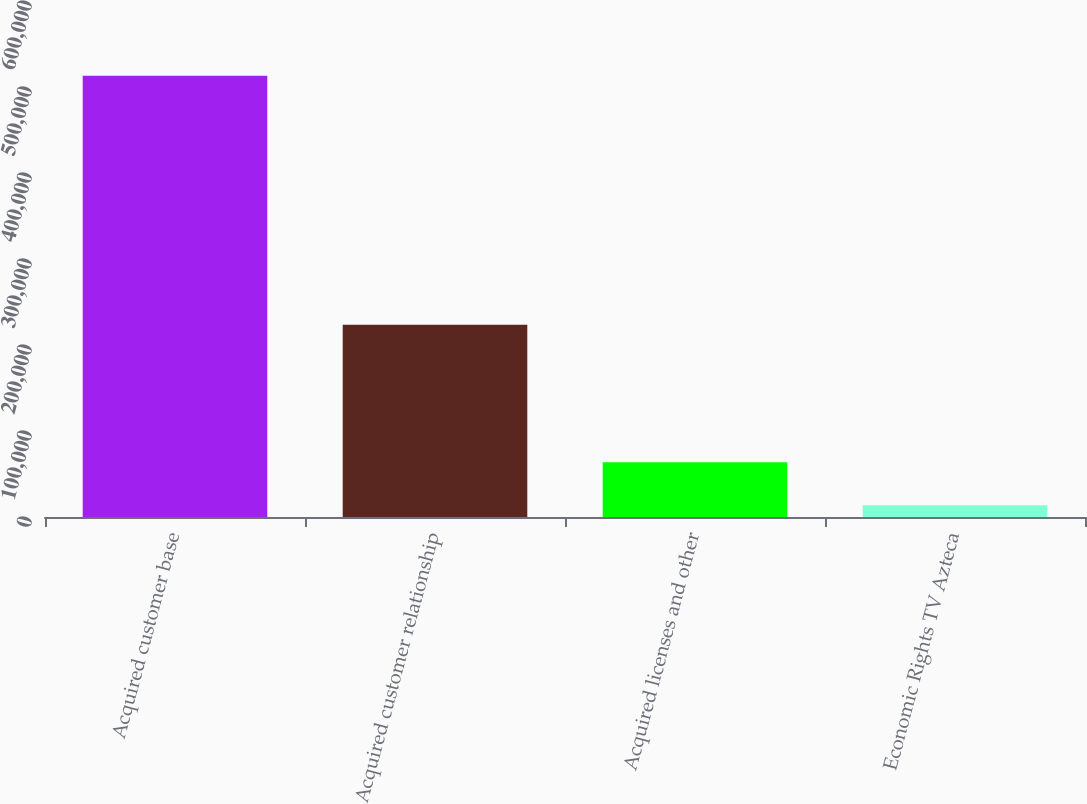<chart> <loc_0><loc_0><loc_500><loc_500><bar_chart><fcel>Acquired customer base<fcel>Acquired customer relationship<fcel>Acquired licenses and other<fcel>Economic Rights TV Azteca<nl><fcel>513223<fcel>223628<fcel>63603.7<fcel>13646<nl></chart> 